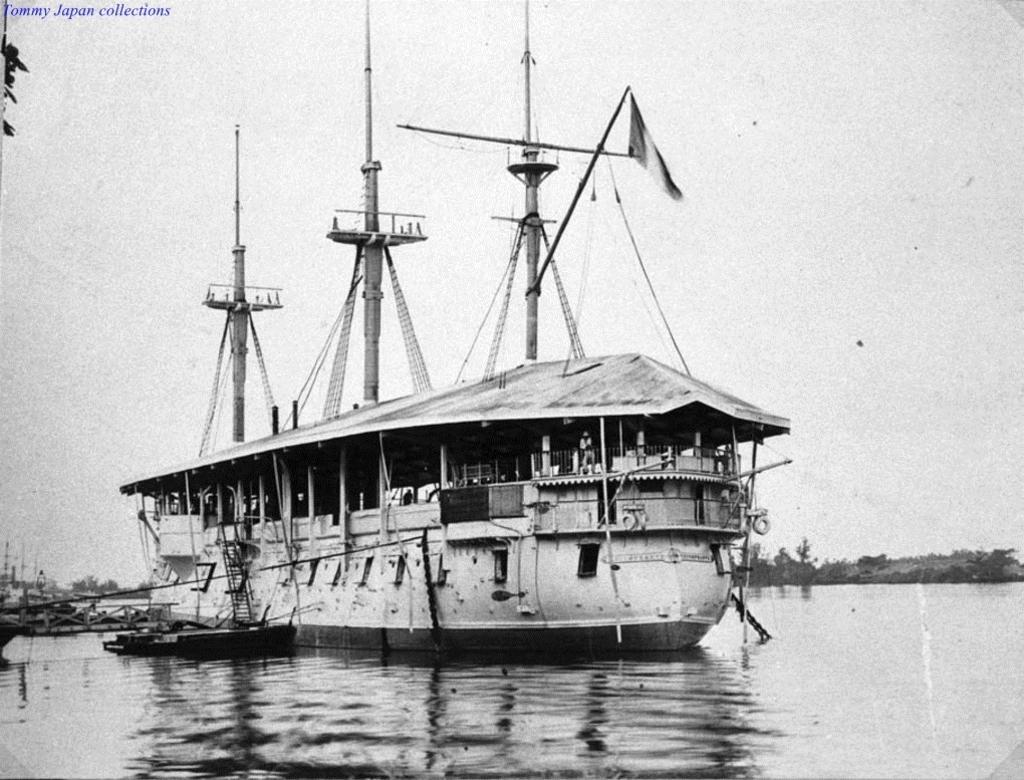Please provide a concise description of this image. In this image I can see the boat on the water. In the background I can see the trees and the sky. And this is a black and white image. 